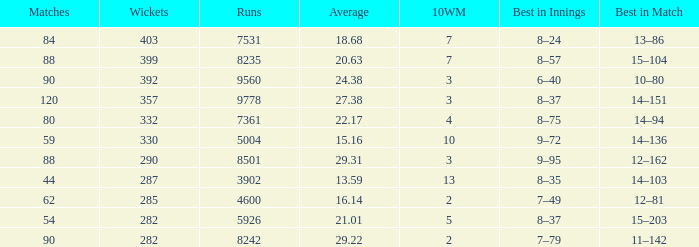What is the total number of wickets that have runs under 4600 and matches under 44? None. 